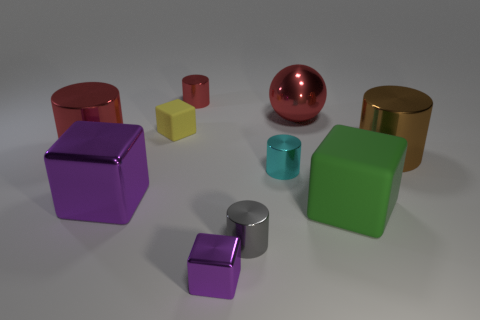What does the arrangement of these objects tell us about their potential use? The arrangement seems methodical and spaced out, suggesting that these objects might be part of a display or a collection. Their careful placement indicates they could have a more decorative purpose rather than a practical one.  Could there be a symbolic meaning behind the colors chosen for these objects? Colors often carry symbolic weight, and in this context, the use of bold, solid colors could signify a playful or modern aesthetic. The specific choice of colors could also represent branding or be part of a thematic collection designed to evoke certain emotions or cultural associations. 